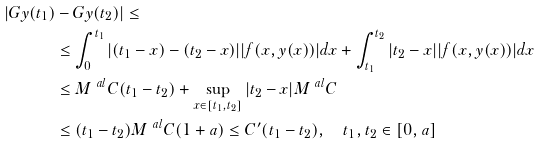Convert formula to latex. <formula><loc_0><loc_0><loc_500><loc_500>| G y ( t _ { 1 } ) & - G y ( t _ { 2 } ) | \leq \\ & \leq \int _ { 0 } ^ { t _ { 1 } } | ( t _ { 1 } - x ) - ( t _ { 2 } - x ) | | f ( x , y ( x ) ) | d x + \int _ { t _ { 1 } } ^ { t _ { 2 } } | t _ { 2 } - x | | f ( x , y ( x ) ) | d x \\ & \leq M ^ { \ a l } C ( t _ { 1 } - t _ { 2 } ) + \sup _ { x \in [ t _ { 1 } , t _ { 2 } ] } | t _ { 2 } - x | M ^ { \ a l } C \\ & \leq ( t _ { 1 } - t _ { 2 } ) M ^ { \ a l } C ( 1 + a ) \leq C ^ { \prime } ( t _ { 1 } - t _ { 2 } ) , \quad t _ { 1 } , t _ { 2 } \in [ 0 , a ]</formula> 